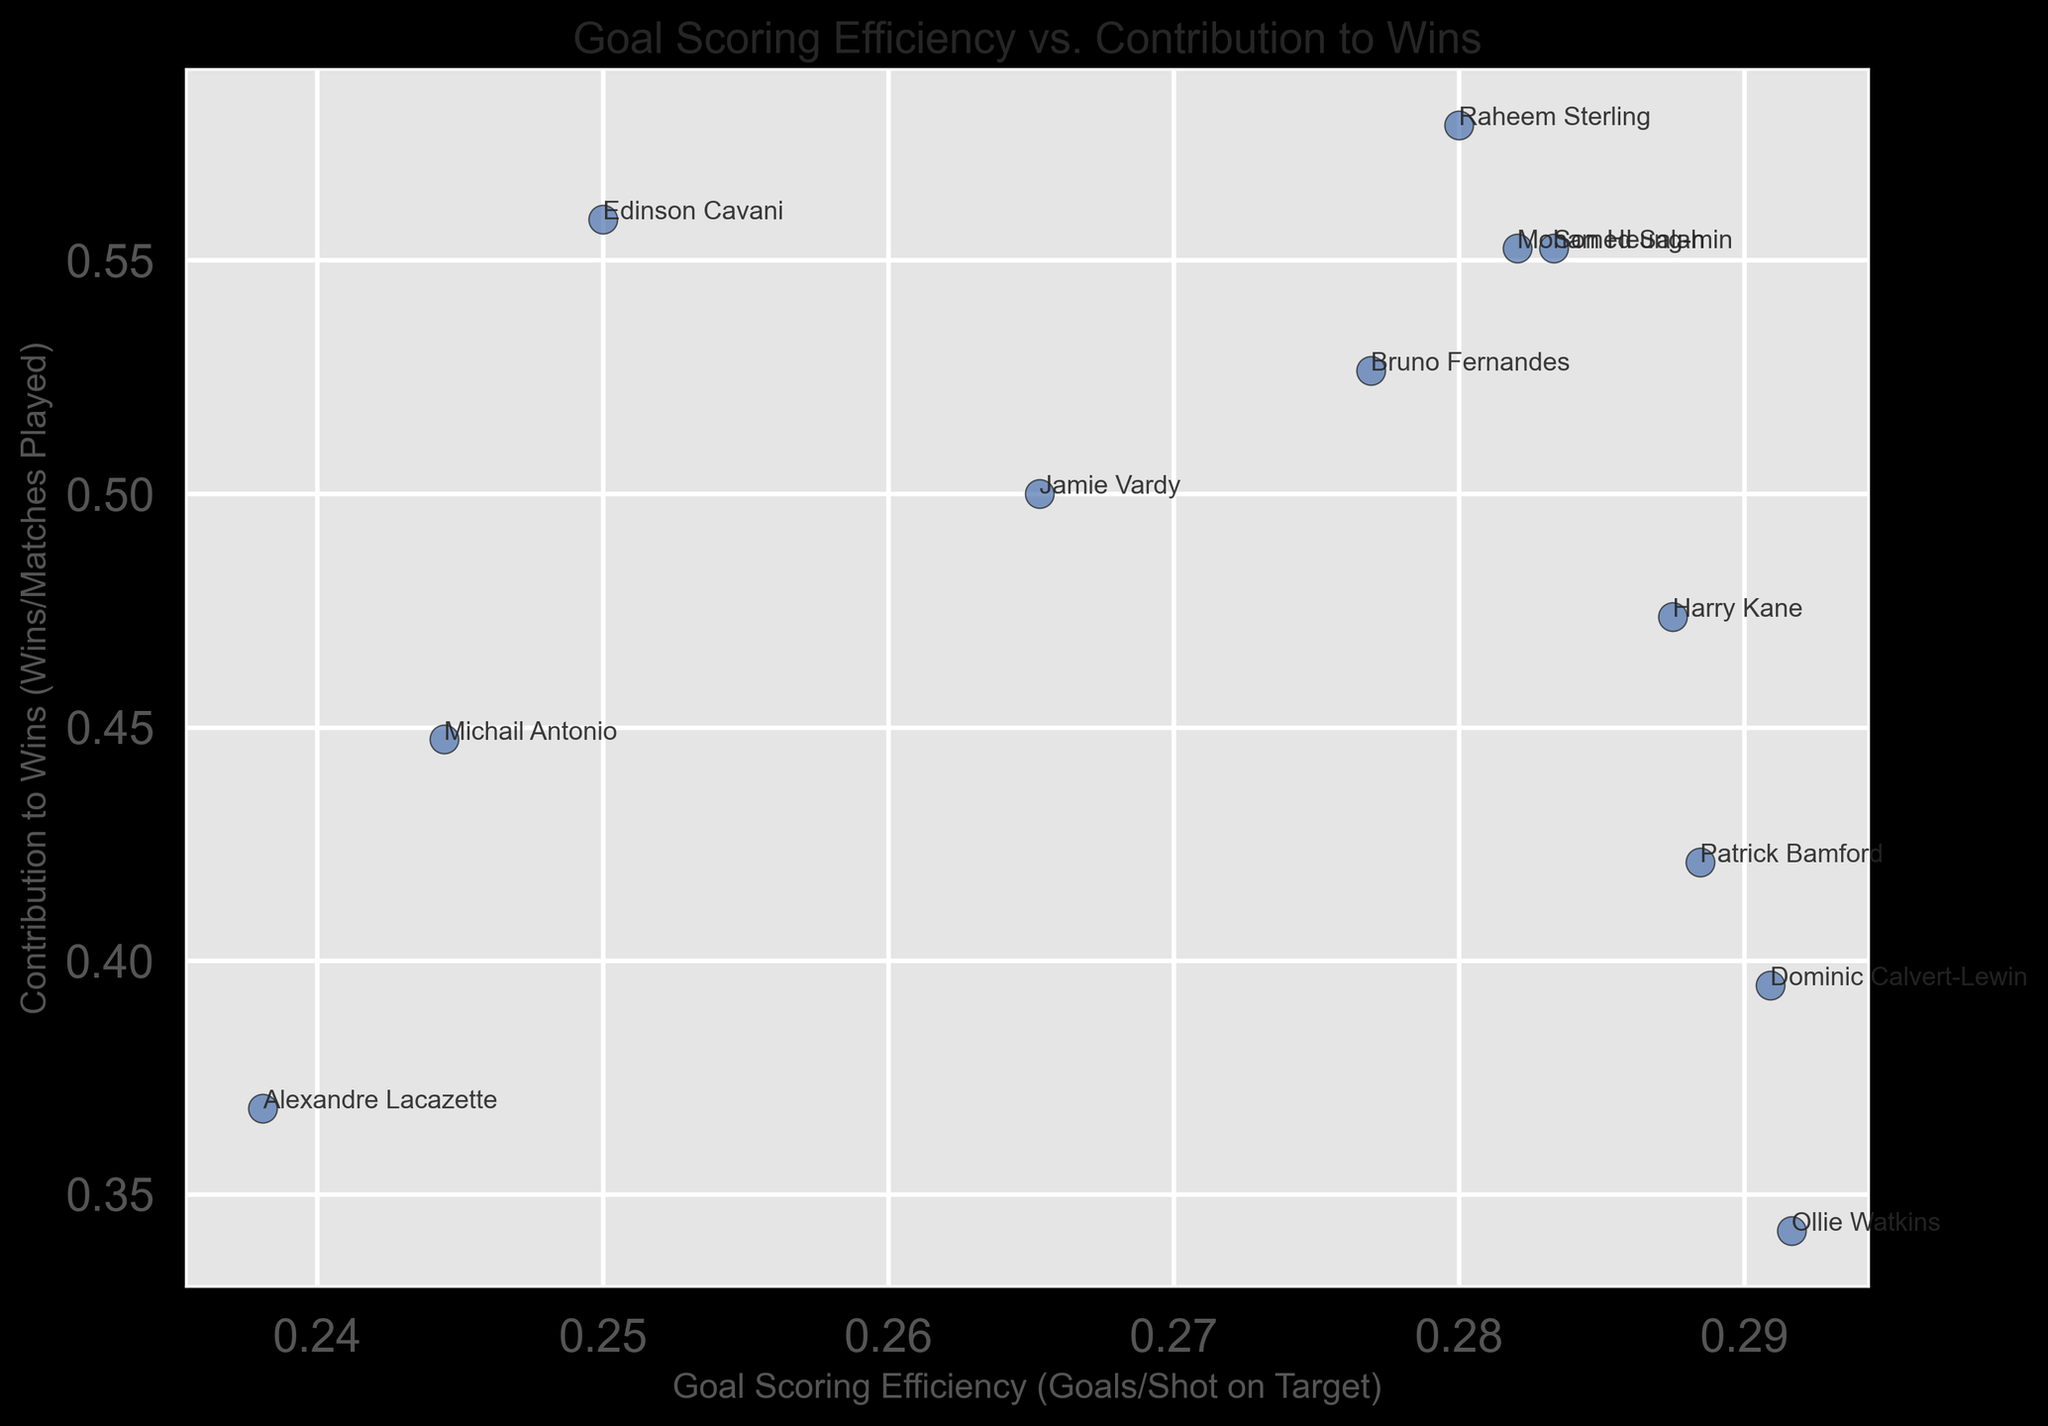What is the goal-scoring efficiency of the player with the highest contribution to wins? From the scatter plot, identify the player with the highest value on the y-axis (Contribution to Wins). Check the x-coordinate of this player to get the Goal Scoring Efficiency.
Answer: Raheem Sterling Which player has the lowest goal-scoring efficiency? Find the point on the scatter plot that has the lowest x-coordinate value, which represents the goal-scoring efficiency. Identify the player name annotated near this point.
Answer: Alexandre Lacazette Who contributed the least to wins, and what is their goal-scoring efficiency? Locate the player with the lowest value on the y-axis, indicating the least contribution to wins. Then, look at their position on the x-axis for their goal-scoring efficiency.
Answer: Ollie Watkins, 0.29 Compare the goal-scoring efficiency between Harry Kane and Bruno Fernandes. Who is more efficient? Identify the points for Harry Kane and Bruno Fernandes on the plot, read the x-coordinates for their respective Goal Scoring Efficiencies, and compare the two values.
Answer: Bruno Fernandes Which player has the closest goal-scoring efficiency to 0.45? Look at the scatter plot and find the player whose point on the x-axis is closest to the value 0.45. Identify the player annotated near this point.
Answer: Son Heung-min Are any players contributing equally to wins (having the same contribution to wins value)? Examine the y-axis for any points that align horizontally, indicating equal contribution to wins. Verify if there are corresponding annotations for multiple players.
Answer: Yes, Bruno Fernandes and Edinson Cavani What is the average goal-scoring efficiency of the top five players in terms of contribution to wins? Locate the top five points on the y-axis (Contribution to Wins) and note their x-coordinate values (Goal Scoring Efficiencies). Calculate the average of these five values.
Answer: 0.43 Who is more effective in terms of contribution to wins: Dominic Calvert-Lewin or Patrick Bamford? Identify the points for Dominic Calvert-Lewin and Patrick Bamford on the plot, read the y-coordinates for their respective Contributions to Wins, and compare the two values.
Answer: Patrick Bamford Which player has the closest contribution to wins to 0.5? Locate the point on the plot with a y-coordinate closest to 0.5, representing the Contribution to Wins, and identify the player annotated near this point.
Answer: Jamie Vardy Is there any player who has both low goal-scoring efficiency and high contribution to wins? Look for a point with a low x-coordinate (Goal Scoring Efficiency) but a high y-coordinate (Contribution to Wins). Identify the player annotated near this point.
Answer: Raheem Sterling 